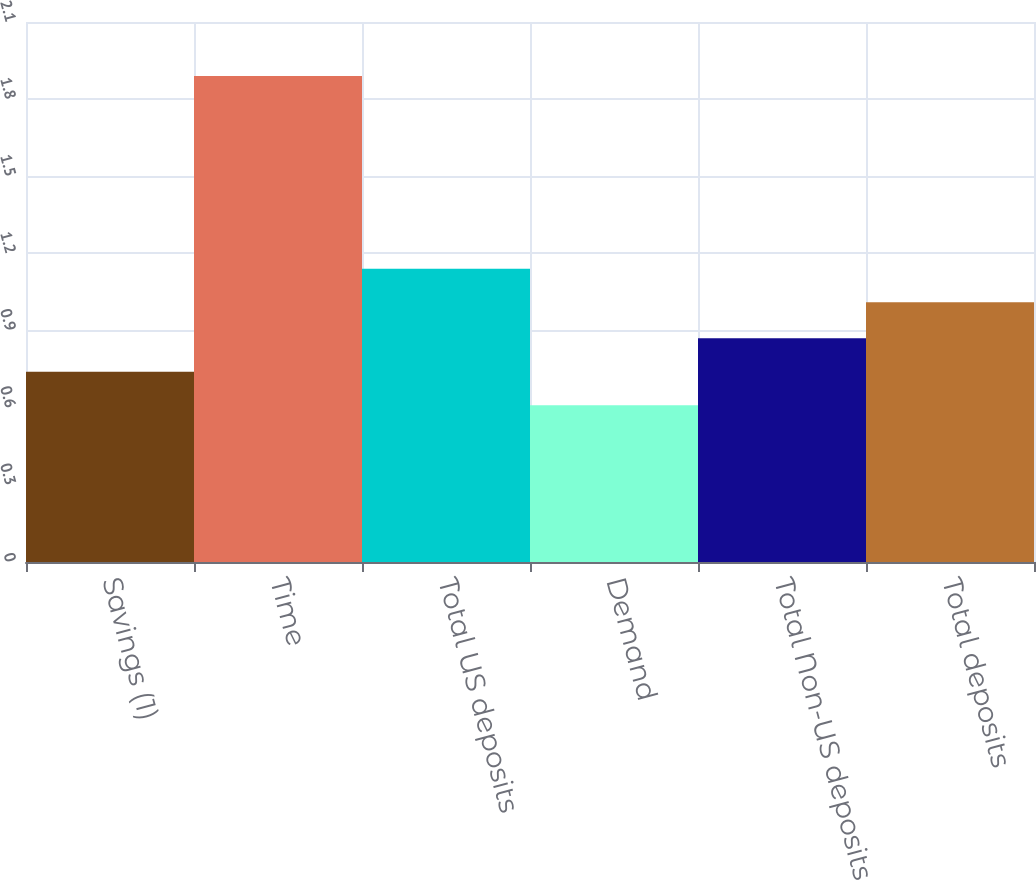Convert chart. <chart><loc_0><loc_0><loc_500><loc_500><bar_chart><fcel>Savings (1)<fcel>Time<fcel>Total US deposits<fcel>Demand<fcel>Total Non-US deposits<fcel>Total deposits<nl><fcel>0.74<fcel>1.89<fcel>1.14<fcel>0.61<fcel>0.87<fcel>1.01<nl></chart> 